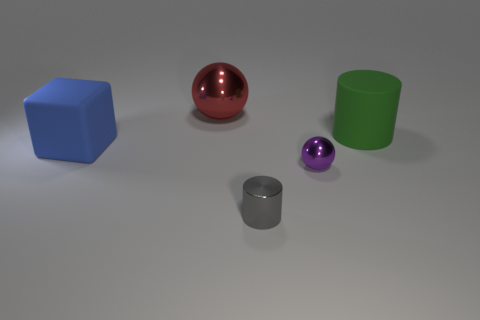Add 5 large blue rubber objects. How many objects exist? 10 Subtract all red objects. Subtract all tiny purple metal things. How many objects are left? 3 Add 4 tiny purple shiny balls. How many tiny purple shiny balls are left? 5 Add 4 big blue rubber cubes. How many big blue rubber cubes exist? 5 Subtract 1 gray cylinders. How many objects are left? 4 Subtract all balls. How many objects are left? 3 